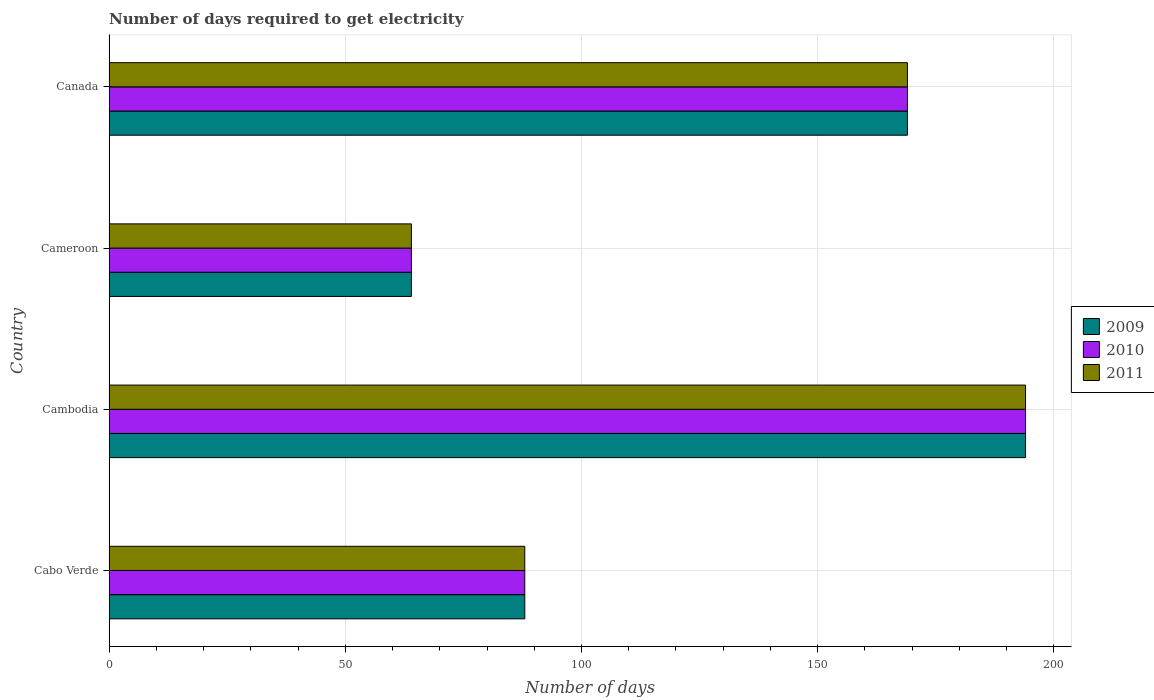Are the number of bars per tick equal to the number of legend labels?
Your response must be concise. Yes. How many bars are there on the 2nd tick from the top?
Give a very brief answer. 3. How many bars are there on the 1st tick from the bottom?
Provide a succinct answer. 3. What is the label of the 4th group of bars from the top?
Ensure brevity in your answer.  Cabo Verde. What is the number of days required to get electricity in in 2009 in Canada?
Your answer should be very brief. 169. Across all countries, what is the maximum number of days required to get electricity in in 2009?
Make the answer very short. 194. Across all countries, what is the minimum number of days required to get electricity in in 2011?
Provide a short and direct response. 64. In which country was the number of days required to get electricity in in 2011 maximum?
Your response must be concise. Cambodia. In which country was the number of days required to get electricity in in 2011 minimum?
Your response must be concise. Cameroon. What is the total number of days required to get electricity in in 2011 in the graph?
Your response must be concise. 515. What is the difference between the number of days required to get electricity in in 2010 in Cabo Verde and the number of days required to get electricity in in 2009 in Cambodia?
Keep it short and to the point. -106. What is the average number of days required to get electricity in in 2010 per country?
Provide a short and direct response. 128.75. What is the ratio of the number of days required to get electricity in in 2011 in Cabo Verde to that in Cambodia?
Make the answer very short. 0.45. Is the number of days required to get electricity in in 2011 in Cabo Verde less than that in Cameroon?
Make the answer very short. No. Is the difference between the number of days required to get electricity in in 2010 in Cabo Verde and Canada greater than the difference between the number of days required to get electricity in in 2009 in Cabo Verde and Canada?
Give a very brief answer. No. What is the difference between the highest and the lowest number of days required to get electricity in in 2011?
Give a very brief answer. 130. What does the 3rd bar from the bottom in Cameroon represents?
Ensure brevity in your answer.  2011. Are all the bars in the graph horizontal?
Offer a terse response. Yes. How many countries are there in the graph?
Give a very brief answer. 4. What is the difference between two consecutive major ticks on the X-axis?
Your answer should be very brief. 50. Are the values on the major ticks of X-axis written in scientific E-notation?
Your response must be concise. No. Does the graph contain any zero values?
Offer a terse response. No. Does the graph contain grids?
Offer a very short reply. Yes. Where does the legend appear in the graph?
Your response must be concise. Center right. How many legend labels are there?
Provide a short and direct response. 3. What is the title of the graph?
Provide a succinct answer. Number of days required to get electricity. What is the label or title of the X-axis?
Your answer should be compact. Number of days. What is the label or title of the Y-axis?
Your response must be concise. Country. What is the Number of days of 2010 in Cabo Verde?
Offer a very short reply. 88. What is the Number of days of 2009 in Cambodia?
Offer a terse response. 194. What is the Number of days in 2010 in Cambodia?
Offer a terse response. 194. What is the Number of days in 2011 in Cambodia?
Keep it short and to the point. 194. What is the Number of days in 2009 in Cameroon?
Provide a succinct answer. 64. What is the Number of days of 2009 in Canada?
Give a very brief answer. 169. What is the Number of days in 2010 in Canada?
Offer a very short reply. 169. What is the Number of days of 2011 in Canada?
Offer a very short reply. 169. Across all countries, what is the maximum Number of days in 2009?
Keep it short and to the point. 194. Across all countries, what is the maximum Number of days of 2010?
Give a very brief answer. 194. Across all countries, what is the maximum Number of days in 2011?
Your answer should be very brief. 194. Across all countries, what is the minimum Number of days in 2009?
Offer a terse response. 64. What is the total Number of days of 2009 in the graph?
Your response must be concise. 515. What is the total Number of days of 2010 in the graph?
Your answer should be compact. 515. What is the total Number of days in 2011 in the graph?
Your answer should be very brief. 515. What is the difference between the Number of days of 2009 in Cabo Verde and that in Cambodia?
Your answer should be very brief. -106. What is the difference between the Number of days in 2010 in Cabo Verde and that in Cambodia?
Offer a very short reply. -106. What is the difference between the Number of days in 2011 in Cabo Verde and that in Cambodia?
Provide a short and direct response. -106. What is the difference between the Number of days in 2010 in Cabo Verde and that in Cameroon?
Your response must be concise. 24. What is the difference between the Number of days of 2009 in Cabo Verde and that in Canada?
Offer a very short reply. -81. What is the difference between the Number of days of 2010 in Cabo Verde and that in Canada?
Make the answer very short. -81. What is the difference between the Number of days of 2011 in Cabo Verde and that in Canada?
Your answer should be compact. -81. What is the difference between the Number of days in 2009 in Cambodia and that in Cameroon?
Your response must be concise. 130. What is the difference between the Number of days of 2010 in Cambodia and that in Cameroon?
Your answer should be very brief. 130. What is the difference between the Number of days in 2011 in Cambodia and that in Cameroon?
Make the answer very short. 130. What is the difference between the Number of days in 2009 in Cambodia and that in Canada?
Your answer should be very brief. 25. What is the difference between the Number of days in 2011 in Cambodia and that in Canada?
Make the answer very short. 25. What is the difference between the Number of days in 2009 in Cameroon and that in Canada?
Your response must be concise. -105. What is the difference between the Number of days of 2010 in Cameroon and that in Canada?
Your answer should be very brief. -105. What is the difference between the Number of days of 2011 in Cameroon and that in Canada?
Ensure brevity in your answer.  -105. What is the difference between the Number of days in 2009 in Cabo Verde and the Number of days in 2010 in Cambodia?
Ensure brevity in your answer.  -106. What is the difference between the Number of days of 2009 in Cabo Verde and the Number of days of 2011 in Cambodia?
Your response must be concise. -106. What is the difference between the Number of days in 2010 in Cabo Verde and the Number of days in 2011 in Cambodia?
Your answer should be very brief. -106. What is the difference between the Number of days of 2009 in Cabo Verde and the Number of days of 2011 in Cameroon?
Keep it short and to the point. 24. What is the difference between the Number of days of 2009 in Cabo Verde and the Number of days of 2010 in Canada?
Offer a very short reply. -81. What is the difference between the Number of days in 2009 in Cabo Verde and the Number of days in 2011 in Canada?
Your response must be concise. -81. What is the difference between the Number of days in 2010 in Cabo Verde and the Number of days in 2011 in Canada?
Provide a succinct answer. -81. What is the difference between the Number of days in 2009 in Cambodia and the Number of days in 2010 in Cameroon?
Provide a succinct answer. 130. What is the difference between the Number of days of 2009 in Cambodia and the Number of days of 2011 in Cameroon?
Your answer should be very brief. 130. What is the difference between the Number of days of 2010 in Cambodia and the Number of days of 2011 in Cameroon?
Your answer should be very brief. 130. What is the difference between the Number of days in 2009 in Cambodia and the Number of days in 2011 in Canada?
Provide a succinct answer. 25. What is the difference between the Number of days of 2009 in Cameroon and the Number of days of 2010 in Canada?
Provide a succinct answer. -105. What is the difference between the Number of days in 2009 in Cameroon and the Number of days in 2011 in Canada?
Offer a very short reply. -105. What is the difference between the Number of days of 2010 in Cameroon and the Number of days of 2011 in Canada?
Keep it short and to the point. -105. What is the average Number of days of 2009 per country?
Provide a short and direct response. 128.75. What is the average Number of days in 2010 per country?
Your answer should be compact. 128.75. What is the average Number of days of 2011 per country?
Your answer should be compact. 128.75. What is the difference between the Number of days of 2009 and Number of days of 2011 in Cabo Verde?
Your answer should be very brief. 0. What is the difference between the Number of days in 2010 and Number of days in 2011 in Cabo Verde?
Your answer should be very brief. 0. What is the difference between the Number of days in 2009 and Number of days in 2010 in Cambodia?
Provide a short and direct response. 0. What is the difference between the Number of days of 2009 and Number of days of 2011 in Cambodia?
Ensure brevity in your answer.  0. What is the difference between the Number of days of 2010 and Number of days of 2011 in Cambodia?
Your answer should be very brief. 0. What is the difference between the Number of days in 2009 and Number of days in 2010 in Cameroon?
Keep it short and to the point. 0. What is the difference between the Number of days in 2009 and Number of days in 2011 in Cameroon?
Keep it short and to the point. 0. What is the difference between the Number of days of 2010 and Number of days of 2011 in Cameroon?
Your answer should be very brief. 0. What is the difference between the Number of days in 2009 and Number of days in 2010 in Canada?
Offer a terse response. 0. What is the ratio of the Number of days in 2009 in Cabo Verde to that in Cambodia?
Your response must be concise. 0.45. What is the ratio of the Number of days in 2010 in Cabo Verde to that in Cambodia?
Your answer should be very brief. 0.45. What is the ratio of the Number of days of 2011 in Cabo Verde to that in Cambodia?
Your answer should be very brief. 0.45. What is the ratio of the Number of days in 2009 in Cabo Verde to that in Cameroon?
Your answer should be compact. 1.38. What is the ratio of the Number of days in 2010 in Cabo Verde to that in Cameroon?
Keep it short and to the point. 1.38. What is the ratio of the Number of days of 2011 in Cabo Verde to that in Cameroon?
Ensure brevity in your answer.  1.38. What is the ratio of the Number of days in 2009 in Cabo Verde to that in Canada?
Your response must be concise. 0.52. What is the ratio of the Number of days in 2010 in Cabo Verde to that in Canada?
Provide a short and direct response. 0.52. What is the ratio of the Number of days in 2011 in Cabo Verde to that in Canada?
Offer a terse response. 0.52. What is the ratio of the Number of days of 2009 in Cambodia to that in Cameroon?
Your response must be concise. 3.03. What is the ratio of the Number of days in 2010 in Cambodia to that in Cameroon?
Ensure brevity in your answer.  3.03. What is the ratio of the Number of days in 2011 in Cambodia to that in Cameroon?
Give a very brief answer. 3.03. What is the ratio of the Number of days in 2009 in Cambodia to that in Canada?
Make the answer very short. 1.15. What is the ratio of the Number of days of 2010 in Cambodia to that in Canada?
Offer a very short reply. 1.15. What is the ratio of the Number of days of 2011 in Cambodia to that in Canada?
Provide a short and direct response. 1.15. What is the ratio of the Number of days in 2009 in Cameroon to that in Canada?
Your response must be concise. 0.38. What is the ratio of the Number of days in 2010 in Cameroon to that in Canada?
Ensure brevity in your answer.  0.38. What is the ratio of the Number of days of 2011 in Cameroon to that in Canada?
Offer a very short reply. 0.38. What is the difference between the highest and the second highest Number of days in 2011?
Keep it short and to the point. 25. What is the difference between the highest and the lowest Number of days in 2009?
Your response must be concise. 130. What is the difference between the highest and the lowest Number of days of 2010?
Provide a short and direct response. 130. What is the difference between the highest and the lowest Number of days of 2011?
Make the answer very short. 130. 